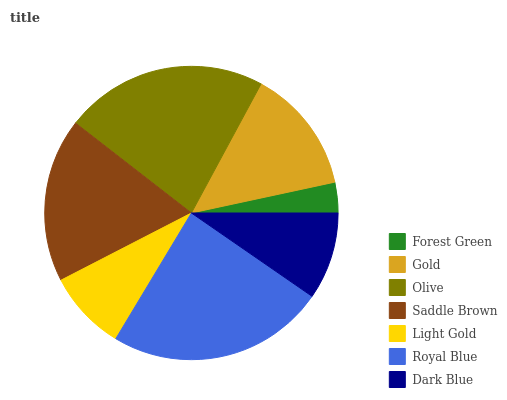Is Forest Green the minimum?
Answer yes or no. Yes. Is Royal Blue the maximum?
Answer yes or no. Yes. Is Gold the minimum?
Answer yes or no. No. Is Gold the maximum?
Answer yes or no. No. Is Gold greater than Forest Green?
Answer yes or no. Yes. Is Forest Green less than Gold?
Answer yes or no. Yes. Is Forest Green greater than Gold?
Answer yes or no. No. Is Gold less than Forest Green?
Answer yes or no. No. Is Gold the high median?
Answer yes or no. Yes. Is Gold the low median?
Answer yes or no. Yes. Is Light Gold the high median?
Answer yes or no. No. Is Saddle Brown the low median?
Answer yes or no. No. 